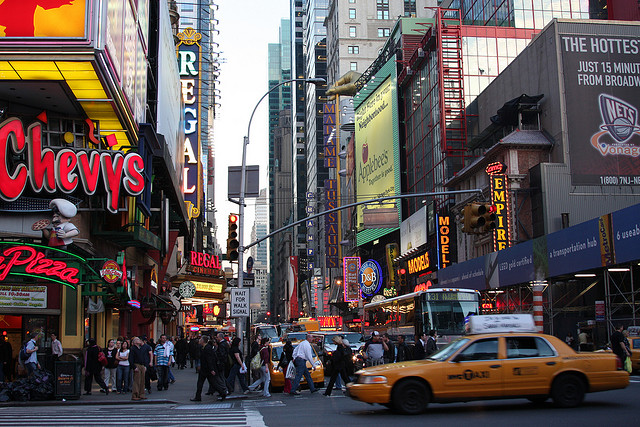Please transcribe the text information in this image. chevys Pizza REGAL MODEL MODELS 31 REGAL 6 Vonag NETS BROADY FROM MINUT 15 JUST HOTTES THE 